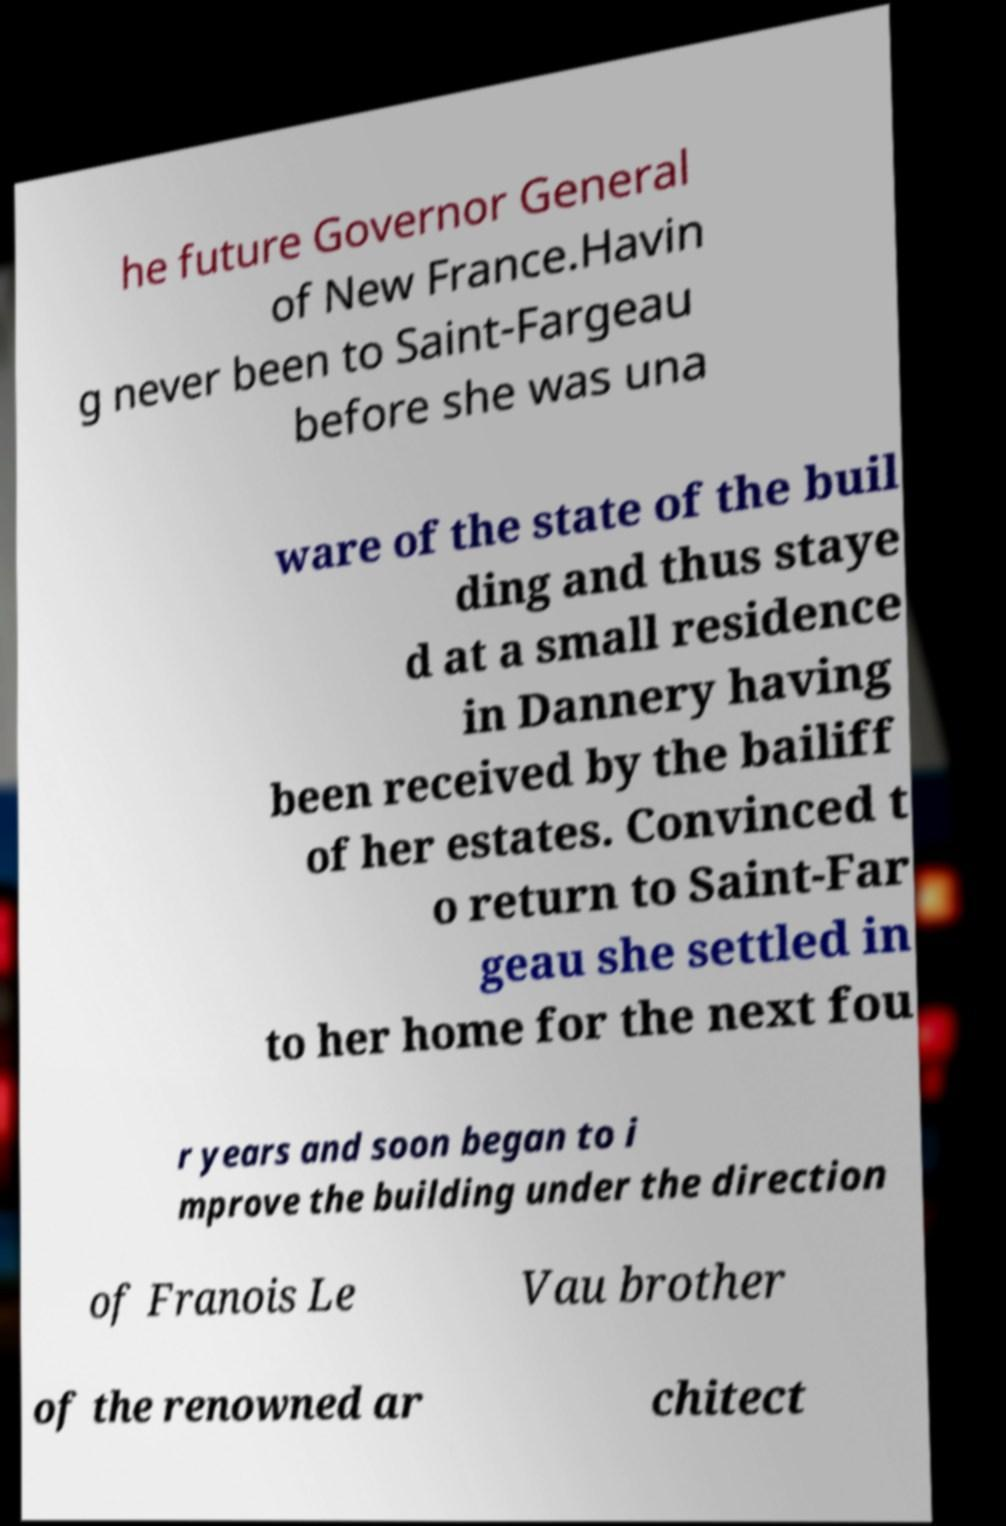What messages or text are displayed in this image? I need them in a readable, typed format. he future Governor General of New France.Havin g never been to Saint-Fargeau before she was una ware of the state of the buil ding and thus staye d at a small residence in Dannery having been received by the bailiff of her estates. Convinced t o return to Saint-Far geau she settled in to her home for the next fou r years and soon began to i mprove the building under the direction of Franois Le Vau brother of the renowned ar chitect 